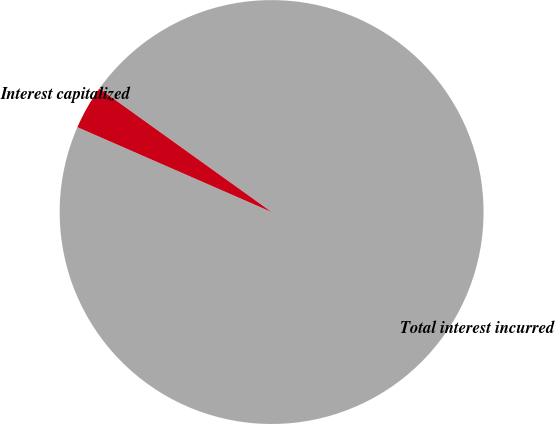Convert chart. <chart><loc_0><loc_0><loc_500><loc_500><pie_chart><fcel>Total interest incurred<fcel>Interest capitalized<nl><fcel>96.66%<fcel>3.34%<nl></chart> 